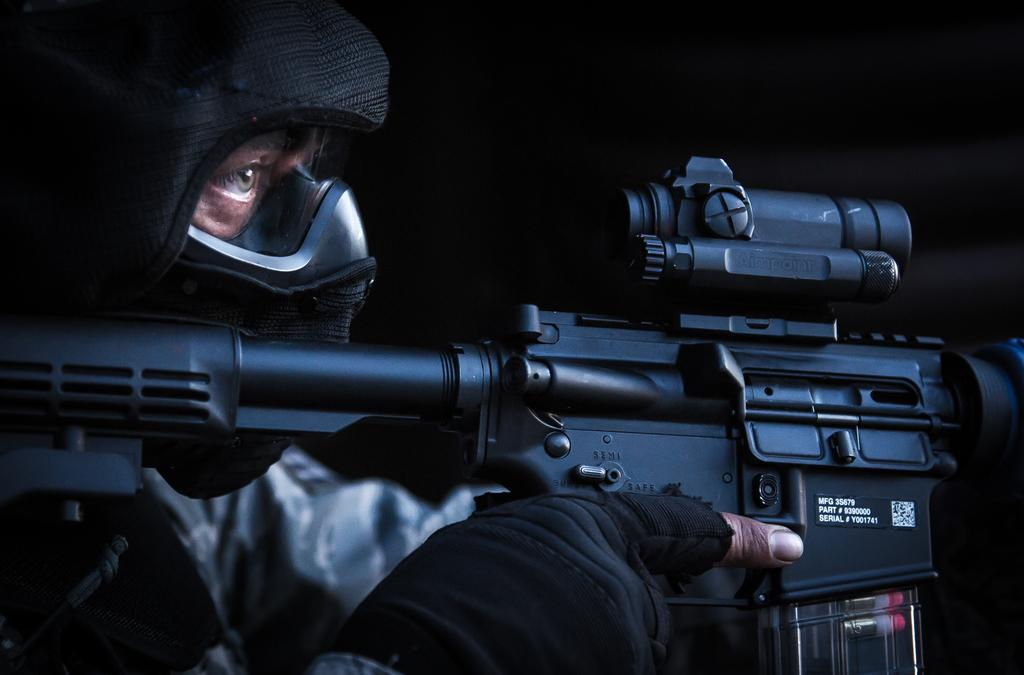What is located on the left side of the image? There is a person on the left side of the image. What is the person wearing? The person is wearing a jacket and a mask. What object is the person holding? The person is holding a gun. What can be observed about the background of the image? The background of the image is dark. What type of butter is being used to grease the pot in the image? There is no butter or pot present in the image; it features a person wearing a jacket, mask, and holding a gun. Is the person wearing a ring on their finger in the image? There is no mention of a ring in the image; the person is wearing a jacket, mask, and holding a gun. 